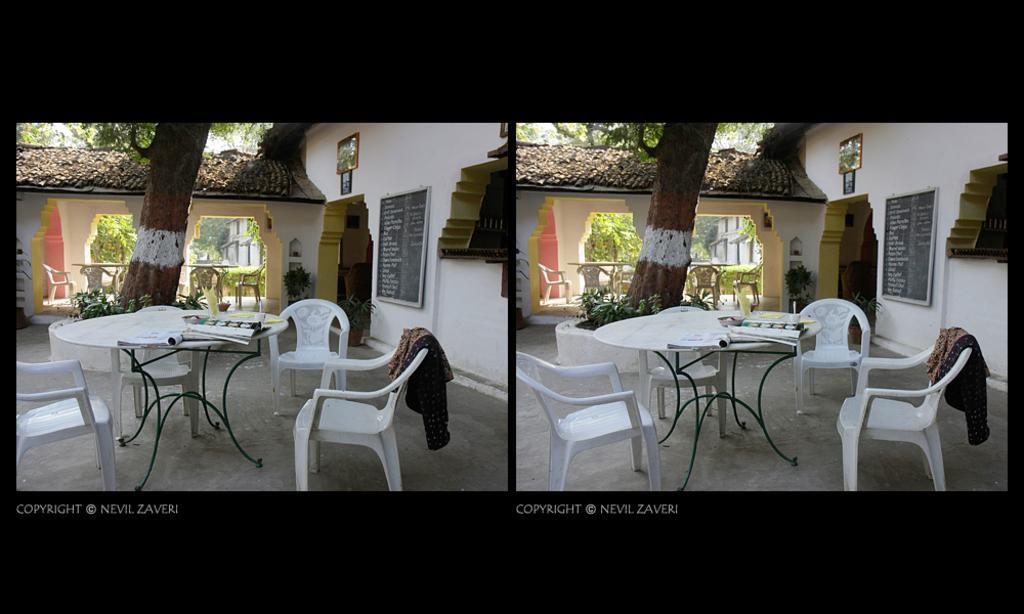How would you summarize this image in a sentence or two? In this image we can see a collage of two pictures. In which we can see a group of chairs and tables placed on the ground, we can also see some objects placed on the table. On the right side of the image we can see a board with some text and a photo frame on the wall. On the left side of the image we can see a building with a roof and a group of trees and plants. At the bottom of the image we can see some text. 